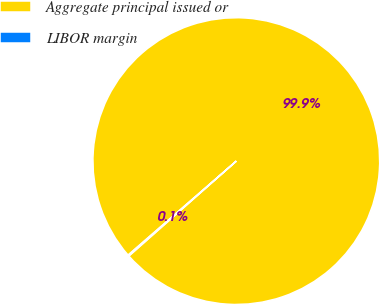Convert chart. <chart><loc_0><loc_0><loc_500><loc_500><pie_chart><fcel>Aggregate principal issued or<fcel>LIBOR margin<nl><fcel>99.87%<fcel>0.13%<nl></chart> 